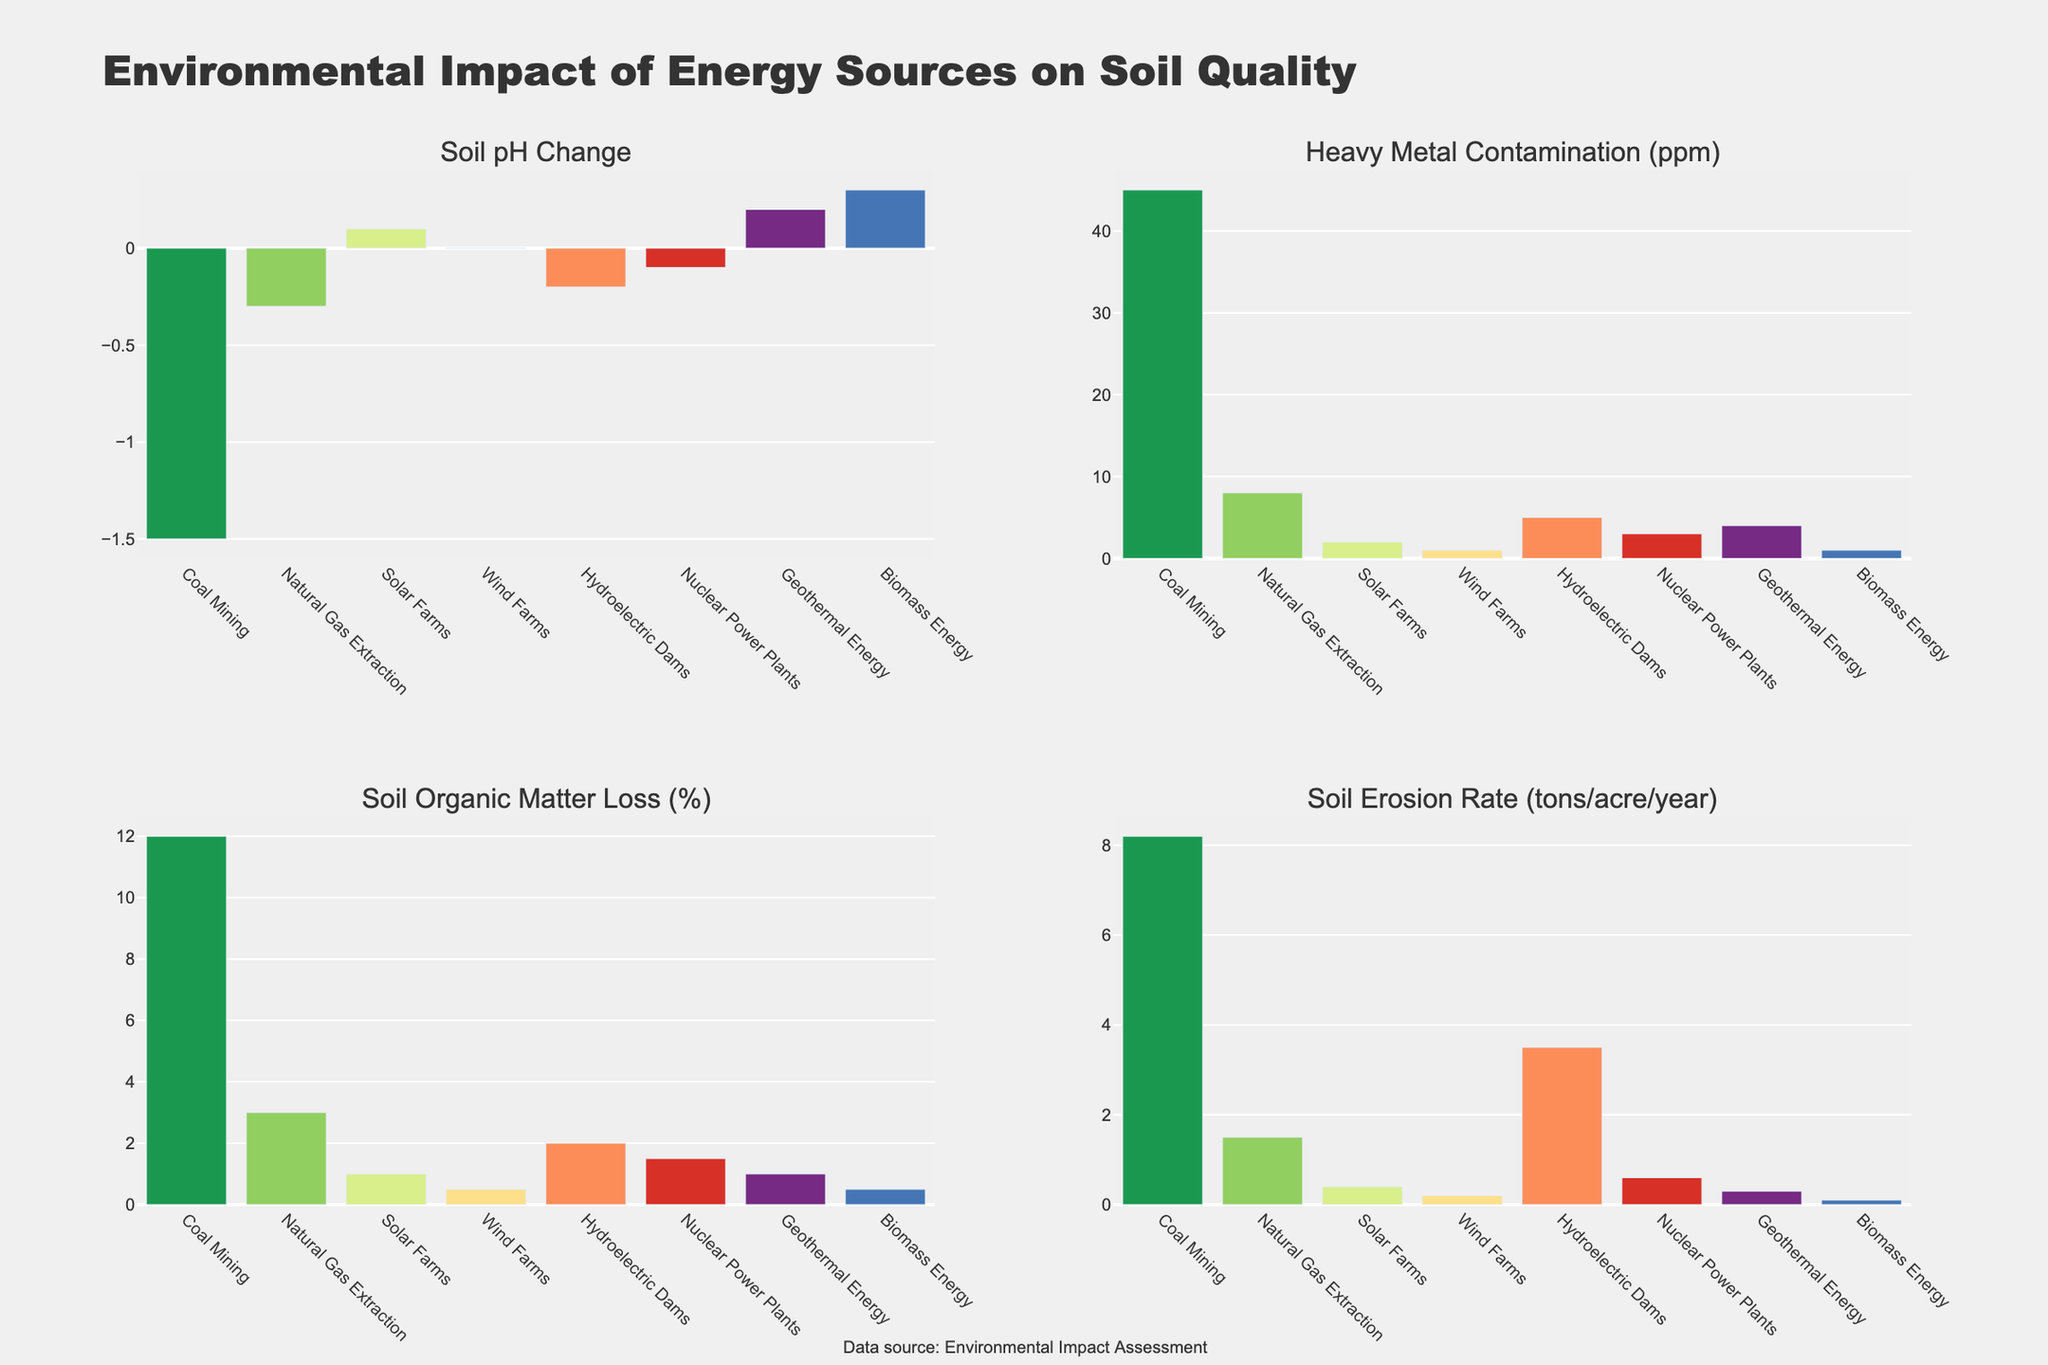Which energy source leads to the greatest soil pH change? Coal mining has the largest negative impact on soil pH with a change of -1.5, which is the most significant in the data.
Answer: Coal mining Which energy source results in the highest heavy metal contamination in ppm? By examining the bar heights in the Heavy Metal Contamination plot, coal mining has the highest contamination with 45 ppm.
Answer: Coal mining Which energy source causes the least soil erosion? Biomass energy shows the smallest bar in the Soil Erosion Rate plot, indicating the lowest erosion at 0.1 tons/acre/year.
Answer: Biomass energy Compare the soil organic matter loss between natural gas extraction and solar farms. The bar heights in the Soil Organic Matter Loss plot show natural gas extraction with a 3% loss and solar farms with a 1% loss. 3% (natural gas extraction) - 1% (solar farms) = 2%.
Answer: Natural Gas Extraction has 2% more loss Which energy source shows a positive change in soil pH? The Soil pH Change plot shows positive values for solar farms, geothermal energy, and biomass energy.
Answer: Solar farms, Geothermal Energy, and Biomass Energy What is the difference in soil erosion between coal mining and wind farms? The Soil Erosion Rate plot shows coal mining at 8.2 tons/acre/year and wind farms at 0.2 tons/acre/year. 8.2 (coal mining) - 0.2 (wind farms) = 8 tons.
Answer: 8 tons/acre/year Which energy source causes the second-least amount of heavy metal contamination? The Heavy Metal Contamination plot indicates wind farms and biomass energy both at 1 ppm, which are tie for the least, and nuclear power plants at 3 ppm comes next.
Answer: Nuclear power plants List the energy sources with soil organic matter loss above 1%. The Soil Organic Matter Loss plot shows coal mining (12%), natural gas extraction (3%), hydroelectric dams (2%), and nuclear power plants (1.5%) above 1%.
Answer: Coal Mining, Natural Gas Extraction, Hydroelectric Dams, Nuclear Power Plants What is the average soil erosion rate of natural gas extraction, solar farms, and wind farms? The Soil Erosion Rate plot shows natural gas extraction at 1.5 tons/acre/year, solar farms at 0.4, and wind farms at 0.2. The average erosion rate is (1.5 + 0.4 + 0.2) / 3 = 0.7 tons/acre/year.
Answer: 0.7 tons/acre/year 